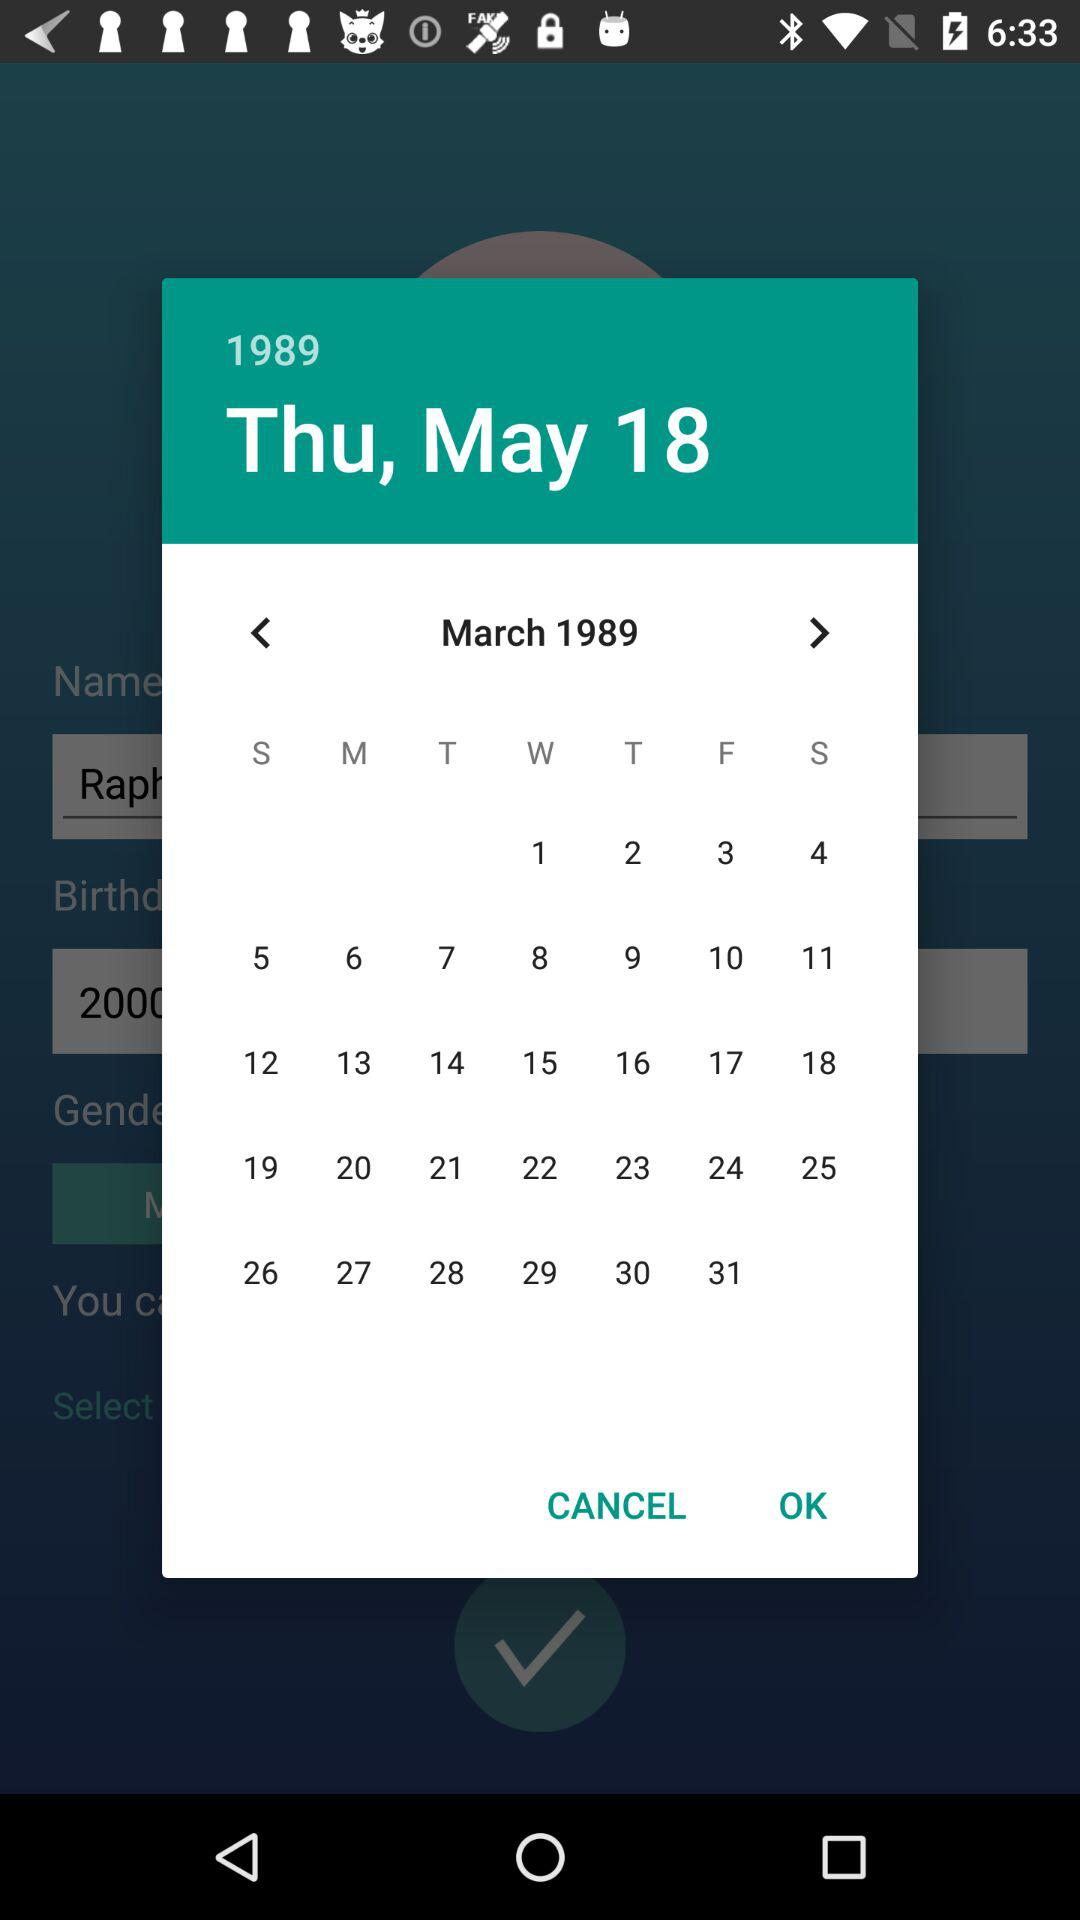What day is March 17, 1989? The day is "Friday". 